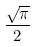Convert formula to latex. <formula><loc_0><loc_0><loc_500><loc_500>\frac { \sqrt { \pi } } { 2 }</formula> 